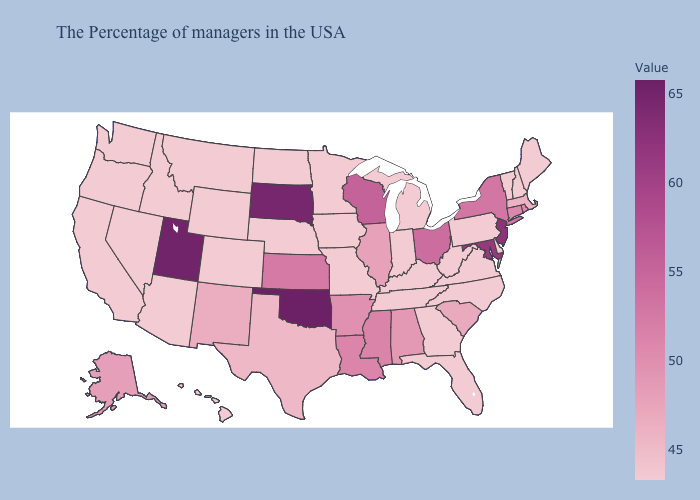Does Maine have the highest value in the Northeast?
Be succinct. No. Does Alaska have a lower value than Maine?
Concise answer only. No. Does Arizona have the highest value in the West?
Be succinct. No. Which states have the highest value in the USA?
Quick response, please. Oklahoma. Does Alaska have the highest value in the USA?
Short answer required. No. Does New Mexico have the lowest value in the USA?
Concise answer only. No. Among the states that border Montana , does Idaho have the highest value?
Keep it brief. No. 